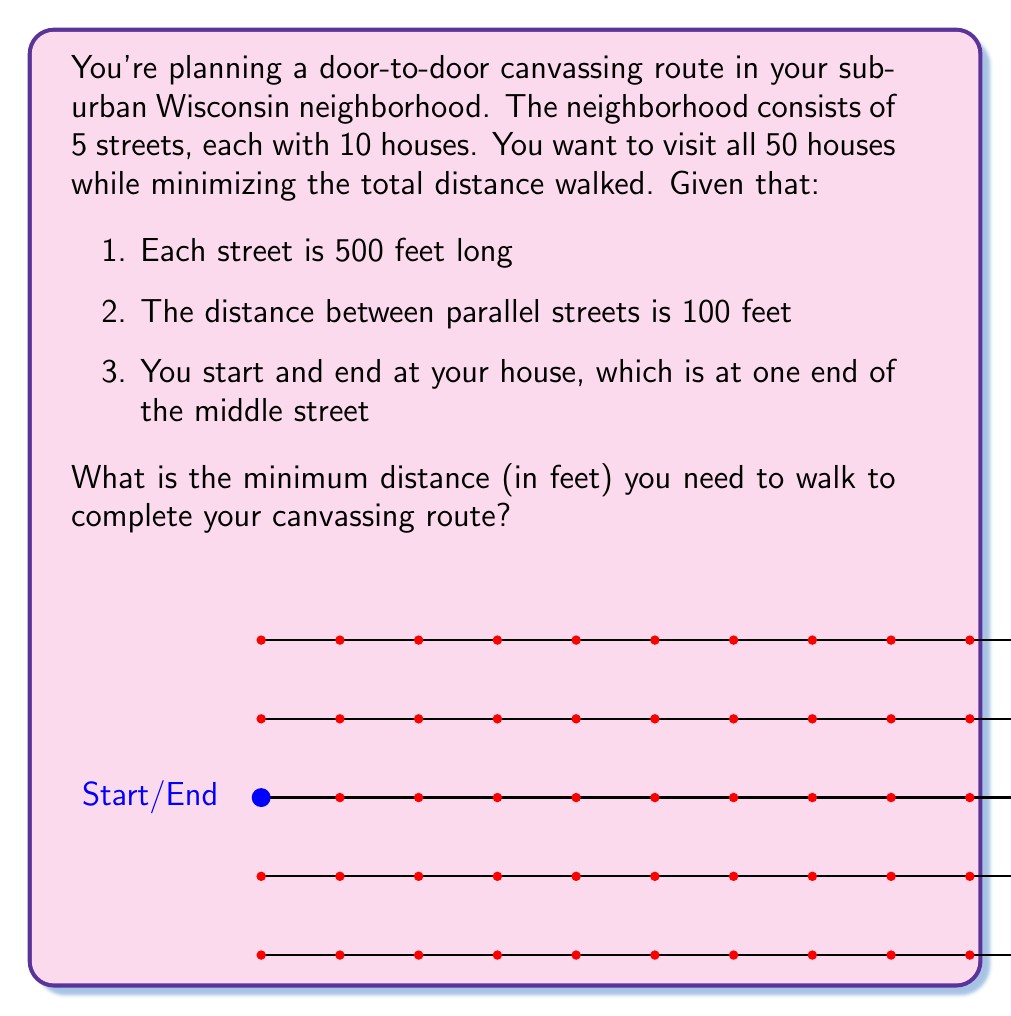Solve this math problem. Let's approach this step-by-step:

1) First, we need to recognize that this is a variation of the Traveling Salesman Problem. The optimal solution is to traverse each street fully before moving to the next one.

2) Starting from your house at one end of the middle street:
   - Walk the length of your street: 500 feet
   - Cross to an adjacent street: 100 feet
   - Walk the length of that street: 500 feet
   - Cross to the next street: 100 feet
   - Repeat until all streets are covered

3) Let's calculate:
   - Total distance walking along streets: $500 \text{ feet} \times 5 \text{ streets} = 2500 \text{ feet}$
   - Total distance crossing between streets: $100 \text{ feet} \times 4 \text{ crossings} = 400 \text{ feet}$

4) Sum these up:
   $$ \text{Total distance} = 2500 \text{ feet} + 400 \text{ feet} = 2900 \text{ feet} $$

5) However, we're not done. Remember, you need to return to your starting point. This means crossing back to your street after finishing the last one:
   $$ \text{Final crossing} = 100 \text{ feet} \times 2 = 200 \text{ feet} $$

6) Therefore, the total minimum distance is:
   $$ \text{Minimum distance} = 2900 \text{ feet} + 200 \text{ feet} = 3100 \text{ feet} $$

This route ensures you visit all houses while minimizing the total distance walked.
Answer: The minimum distance to complete the canvassing route is 3100 feet. 